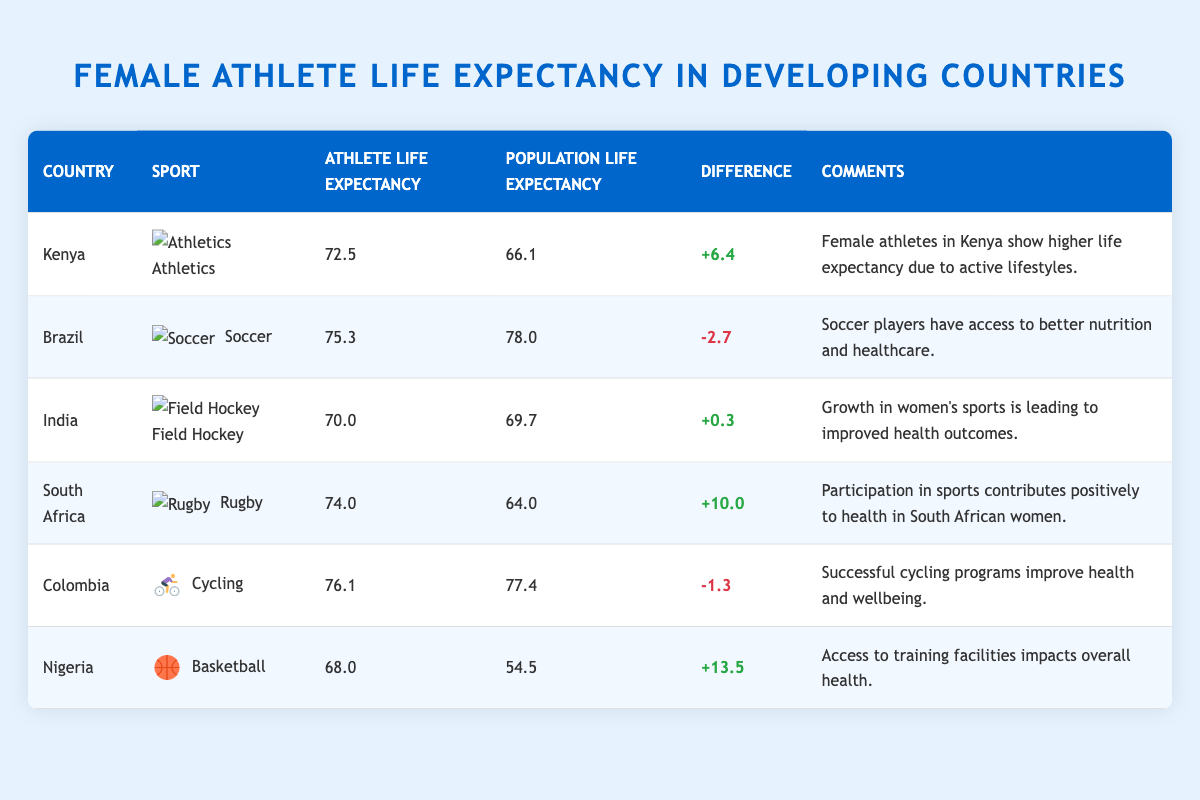What is the life expectancy of female athletes in Brazil? The table directly shows that the life expectancy of female athletes in Brazil is 75.3 years.
Answer: 75.3 Which country has the highest female athlete life expectancy? By comparing the values in the "Female Athlete Life Expectancy" column, Colombia has the highest at 76.1 years.
Answer: Colombia How many years longer do female athletes in South Africa live compared to the general population? The life expectancy of female athletes in South Africa is 74.0 years, while the population's life expectancy is 64.0 years. The difference is calculated as 74.0 - 64.0 = 10.0 years.
Answer: 10.0 Are female athletes in Kenya healthier than the general population? Female athletes have a life expectancy of 72.5 years, which is higher than the population's life expectancy of 66.1 years, indicating that they are likely healthier.
Answer: Yes What is the average life expectancy of female athletes across all listed countries? To find the average, add the life expectancies: (72.5 + 75.3 + 70.0 + 74.0 + 76.1 + 68.0) = 436.9. There are 6 data points, so the average is 436.9 / 6 = 72.82 years.
Answer: 72.82 How does the life expectancy of female athletes in Nigeria compare to that of the population? The life expectancy for female athletes in Nigeria is 68.0 years, while the population's life expectancy is 54.5 years. The female athletes live 13.5 years longer than the general population, showing a positive impact from sports participation.
Answer: Female athletes live 13.5 years longer Is it true that Brazilian female athletes have a life expectancy lower than that of their general population? The life expectancy of female athletes is 75.3 years, while the population's is 78.0 years, indicating it is indeed lower for athletes.
Answer: Yes Which sport has the most significant reported positive effect on life expectancy in South Africa? The table indicates that Rugby in South Africa corresponds to a life expectancy of 74.0 years, with a notable positive health contribution due to athletic participation.
Answer: Rugby If the life expectancy in Colombia is 76.1 years, what is the life expectancy difference between athletes in Kenya and Colombia? Female athletes in Kenya have a life expectancy of 72.5 years. The difference between them is 76.1 - 72.5 = 3.6 years, indicating that Colombian athletes have a higher life expectancy than their Kenyan counterparts.
Answer: 3.6 Which country shows the most significant improvement in life expectancy for female athletes compared to the general female population? By examining the differences, Nigeria shows the most significant improvement with a difference of 13.5 years, suggesting greater health and well-being among athletes.
Answer: Nigeria 